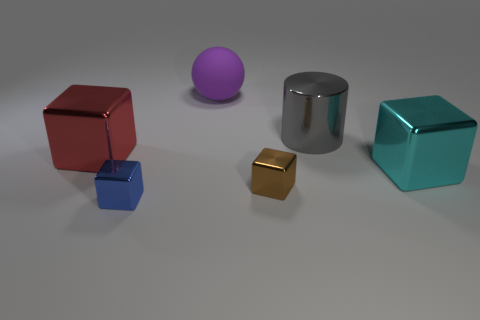The small cube to the right of the big purple object is what color?
Make the answer very short. Brown. How many purple rubber spheres have the same size as the red cube?
Give a very brief answer. 1. There is a small object that is on the right side of the purple thing; does it have the same shape as the object that is on the left side of the blue shiny object?
Offer a terse response. Yes. There is a big thing that is behind the metal object behind the block behind the cyan metal cube; what is it made of?
Keep it short and to the point. Rubber. There is another rubber thing that is the same size as the cyan object; what shape is it?
Your answer should be compact. Sphere. Is there a large block of the same color as the big cylinder?
Keep it short and to the point. No. What size is the cyan thing?
Offer a very short reply. Large. Does the tiny brown object have the same material as the large gray cylinder?
Offer a terse response. Yes. There is a big cube that is in front of the large thing that is to the left of the large purple ball; how many things are left of it?
Ensure brevity in your answer.  5. There is a object that is in front of the brown metal thing; what is its shape?
Your answer should be very brief. Cube. 